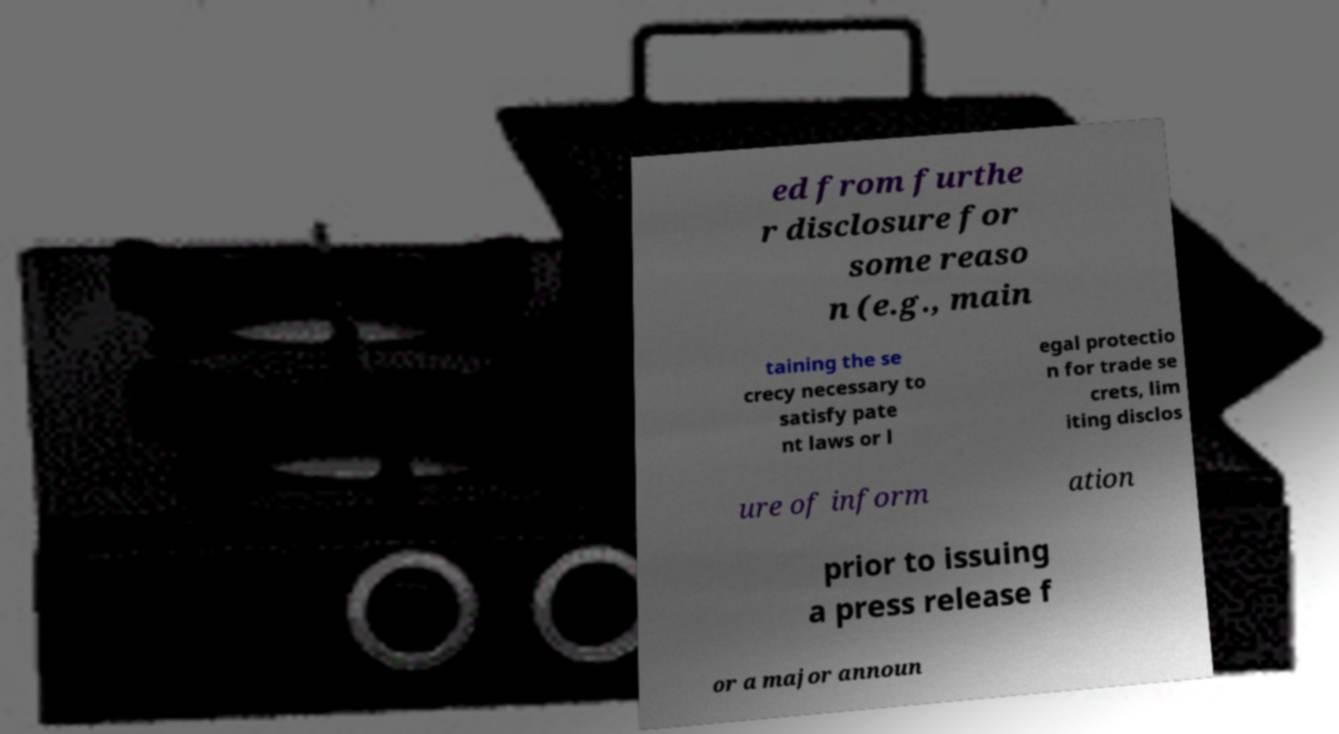Can you accurately transcribe the text from the provided image for me? ed from furthe r disclosure for some reaso n (e.g., main taining the se crecy necessary to satisfy pate nt laws or l egal protectio n for trade se crets, lim iting disclos ure of inform ation prior to issuing a press release f or a major announ 